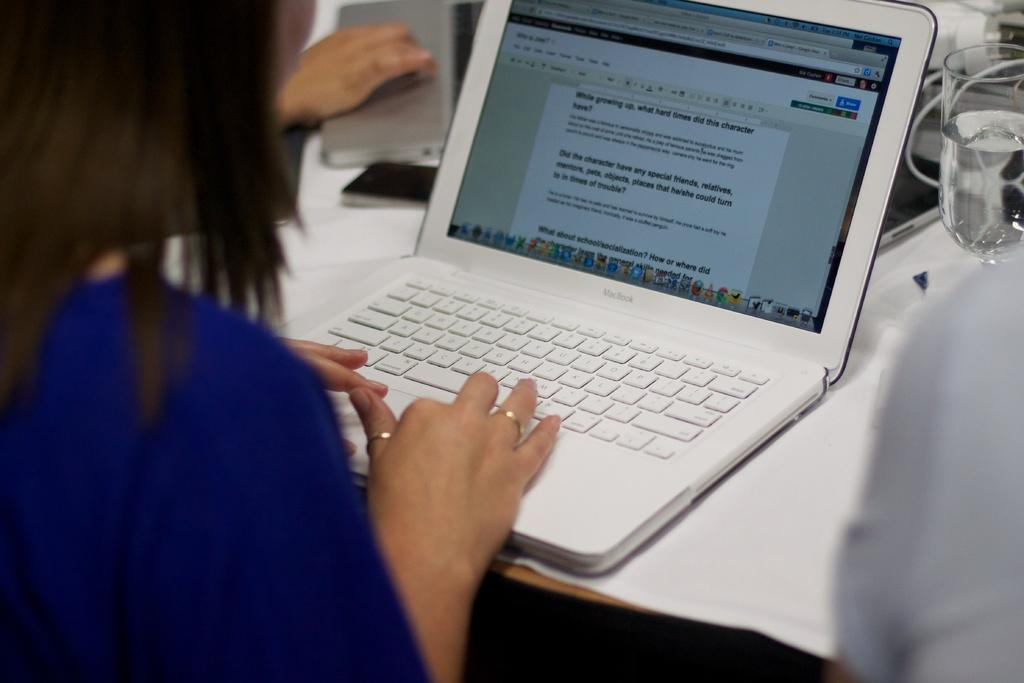What is the woman in the image doing? The woman is sitting in the image. What can be seen on the table in the image? There is a laptop and a glass on the table in the image. What else is present on the table in the image? There are some objects on the table in the image. What type of cave is visible in the background of the image? There is no cave present in the image; it features a woman sitting at a table with a laptop and a glass. 